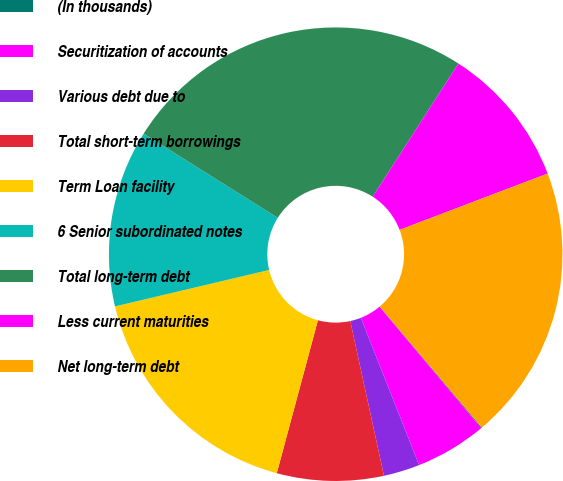Convert chart. <chart><loc_0><loc_0><loc_500><loc_500><pie_chart><fcel>(In thousands)<fcel>Securitization of accounts<fcel>Various debt due to<fcel>Total short-term borrowings<fcel>Term Loan facility<fcel>6 Senior subordinated notes<fcel>Total long-term debt<fcel>Less current maturities<fcel>Net long-term debt<nl><fcel>0.06%<fcel>5.09%<fcel>2.58%<fcel>7.6%<fcel>17.12%<fcel>12.62%<fcel>25.18%<fcel>10.11%<fcel>19.64%<nl></chart> 